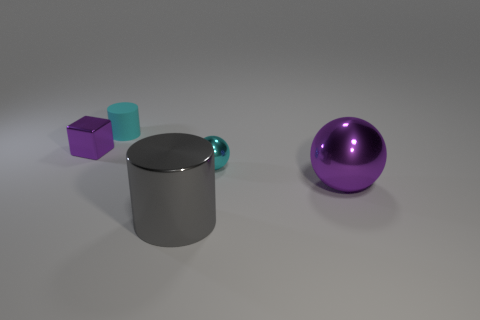Add 4 gray metal things. How many objects exist? 9 Subtract all cylinders. How many objects are left? 3 Subtract 1 gray cylinders. How many objects are left? 4 Subtract all cyan matte objects. Subtract all big green matte objects. How many objects are left? 4 Add 4 shiny balls. How many shiny balls are left? 6 Add 3 gray objects. How many gray objects exist? 4 